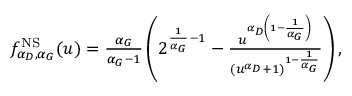Convert formula to latex. <formula><loc_0><loc_0><loc_500><loc_500>\begin{array} { r } { f _ { \alpha _ { D } , \alpha _ { G } } ^ { N S } ( u ) = \frac { \alpha _ { G } } { \alpha _ { G } - 1 } \left ( 2 ^ { \frac { 1 } { \alpha _ { G } } - 1 } - \frac { u ^ { \alpha _ { D } \left ( 1 - \frac { 1 } { \alpha _ { G } } \right ) } } { ( u ^ { \alpha _ { D } } + 1 ) ^ { 1 - \frac { 1 } { \alpha _ { G } } } } \right ) , } \end{array}</formula> 